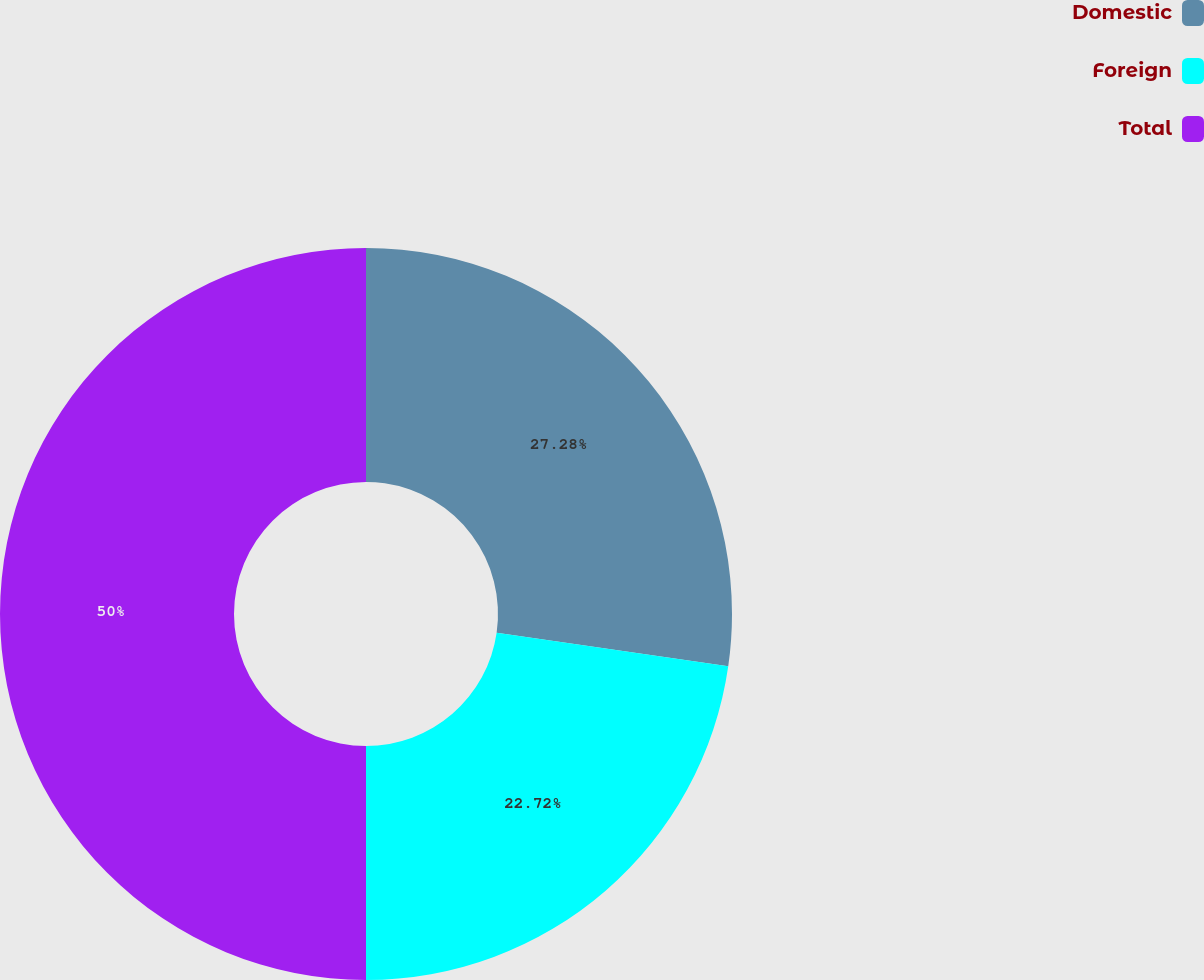Convert chart. <chart><loc_0><loc_0><loc_500><loc_500><pie_chart><fcel>Domestic<fcel>Foreign<fcel>Total<nl><fcel>27.28%<fcel>22.72%<fcel>50.0%<nl></chart> 